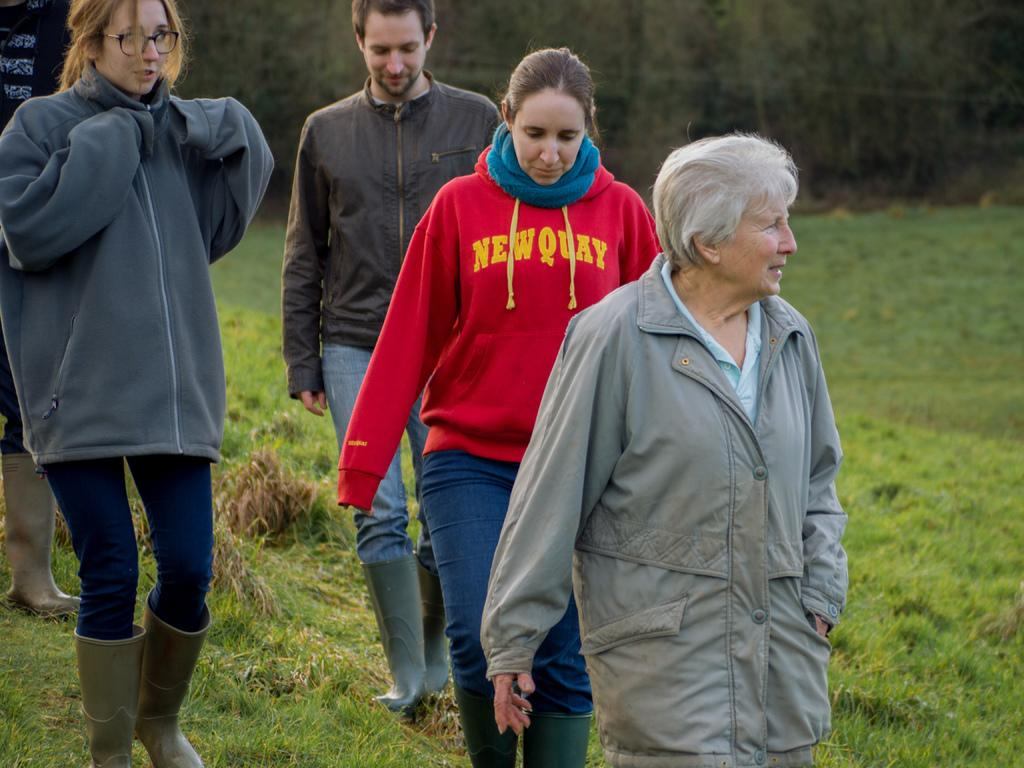What are the people in the image doing? The people in the image are walking. On what surface are the people walking? The people are walking on the ground. What type of vegetation is present on the ground? There is grass on the ground. What can be seen in the background of the image? There are trees in the background of the image. What type of deer can be seen expressing anger in the image? There are no deer present in the image, and no one is expressing anger. 